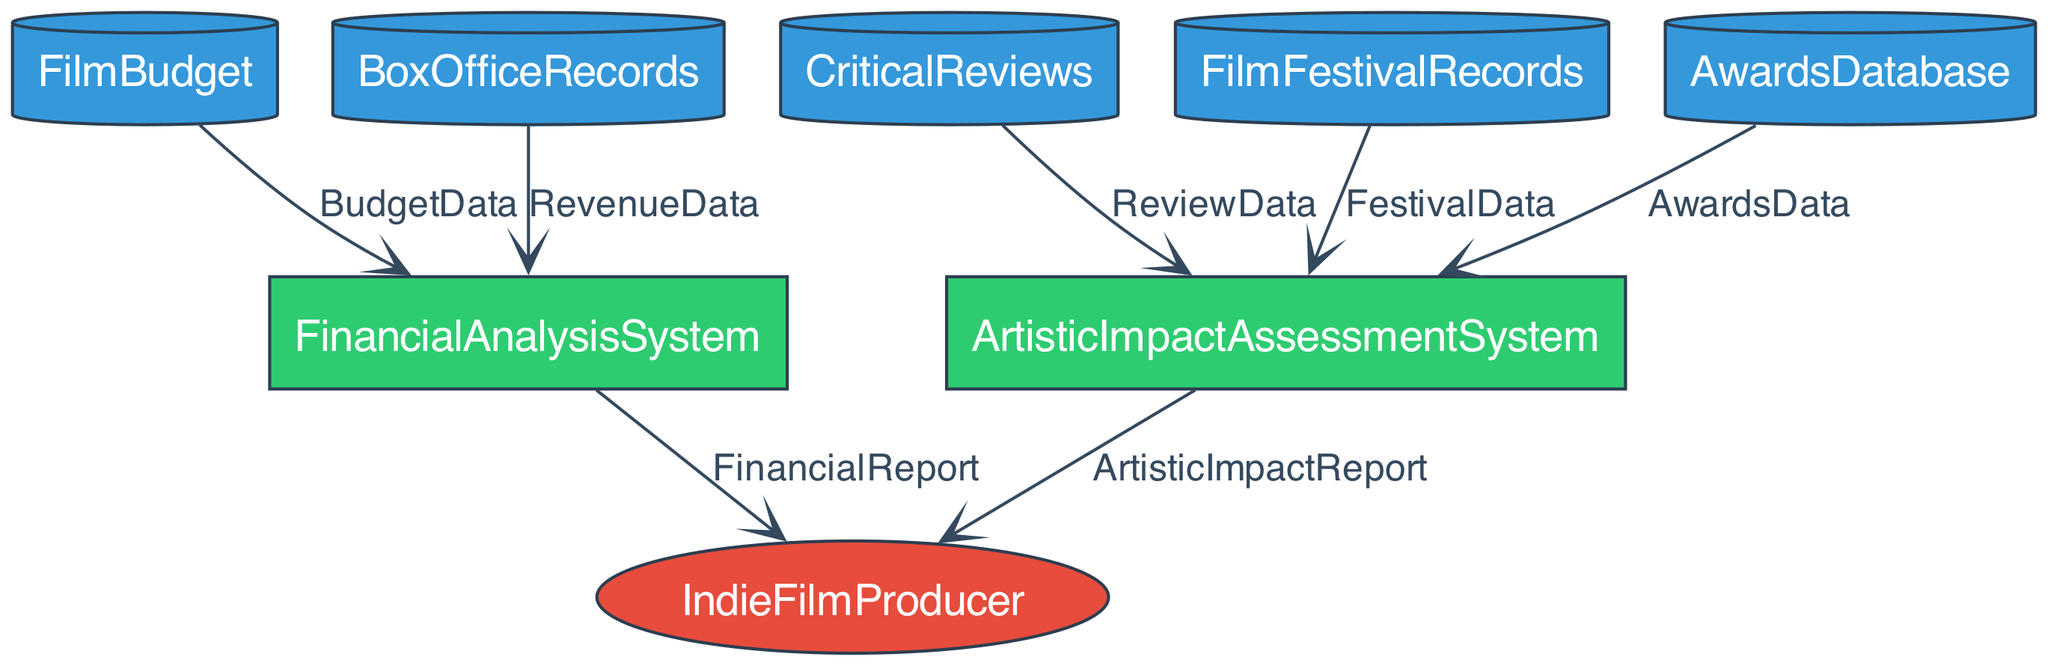What is the role of the IndieFilmProducer? The IndieFilmProducer is an external entity responsible for creating and managing indie films. This is identified as an external entity in the diagram, indicating its key role in the film production process.
Answer: Entity responsible for creating and managing indie films How many data stores are present in the diagram? By examining the diagram, we can count all the nodes labeled as data stores: FilmBudget, CriticalReviews, BoxOfficeRecords, FilmFestivalRecords, and AwardsDatabase. This totals five data stores.
Answer: Five What kind of reports does the FinancialAnalysisSystem produce? The FinancialAnalysisSystem produces the FinancialReport, which summarizes financial performance, including budget adherence and profits. The diagram explicitly shows this data flow and its destination.
Answer: FinancialReport What is the source of the ReviewData? The ReviewData is sourced from CriticalReviews, which is clearly labeled as the database storing critics' reviews and ratings for indie films. The arrow indicating data flow confirms this relationship.
Answer: CriticalReviews Which process receives data from the AwardsDatabase? The ArtisticImpactAssessmentSystem receives data from the AwardsDatabase, as shown by the data flow arrow connecting them. This indicates that it utilizes the awards data for its assessment.
Answer: ArtisticImpactAssessmentSystem What type of data does the FinancialAnalysisSystem analyze? The FinancialAnalysisSystem analyzes both BudgetData from FilmBudget and RevenueData from BoxOfficeRecords. This is evident from the connections and the types of data indicated in the diagram.
Answer: BudgetData and RevenueData How many reports are generated from the two processes? There are two reports generated: the FinancialReport from FinancialAnalysisSystem and the ArtisticImpactReport from ArtisticImpactAssessmentSystem. Counting these two outputs gives us the answer.
Answer: Two What does the FestivalData contain? The FestivalData contains information on film festival screenings and awards, as represented in the diagram indicating its source and purpose for input into the ArtisticImpactAssessmentSystem.
Answer: Information on film festival screenings and awards Which data flows connect to the ArtisticImpactAssessmentSystem? The ArtisticImpactAssessmentSystem receives three data flows: ReviewData from CriticalReviews, FestivalData from FilmFestivalRecords, and AwardsData from AwardsDatabase. Examining the diagram shows three arrows feeding into this process.
Answer: ReviewData, FestivalData, and AwardsData 